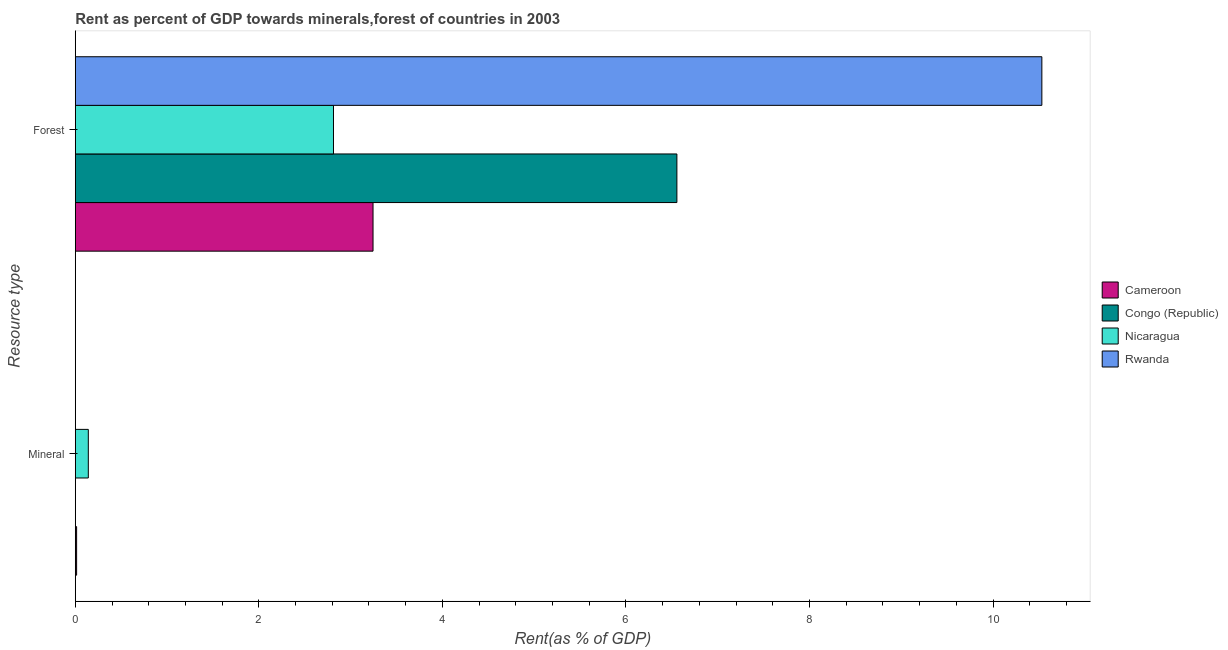How many different coloured bars are there?
Offer a terse response. 4. How many bars are there on the 2nd tick from the top?
Provide a succinct answer. 4. How many bars are there on the 1st tick from the bottom?
Your answer should be compact. 4. What is the label of the 1st group of bars from the top?
Your answer should be very brief. Forest. What is the forest rent in Cameroon?
Your answer should be compact. 3.24. Across all countries, what is the maximum forest rent?
Ensure brevity in your answer.  10.53. Across all countries, what is the minimum forest rent?
Your response must be concise. 2.81. In which country was the forest rent maximum?
Keep it short and to the point. Rwanda. In which country was the forest rent minimum?
Offer a terse response. Nicaragua. What is the total mineral rent in the graph?
Provide a succinct answer. 0.16. What is the difference between the mineral rent in Nicaragua and that in Rwanda?
Offer a terse response. 0.14. What is the difference between the forest rent in Congo (Republic) and the mineral rent in Cameroon?
Make the answer very short. 6.54. What is the average forest rent per country?
Provide a succinct answer. 5.79. What is the difference between the mineral rent and forest rent in Nicaragua?
Your answer should be compact. -2.67. In how many countries, is the forest rent greater than 4 %?
Your response must be concise. 2. What is the ratio of the mineral rent in Congo (Republic) to that in Nicaragua?
Your answer should be compact. 0. Is the mineral rent in Congo (Republic) less than that in Nicaragua?
Offer a very short reply. Yes. What does the 3rd bar from the top in Forest represents?
Ensure brevity in your answer.  Congo (Republic). What does the 3rd bar from the bottom in Mineral represents?
Offer a terse response. Nicaragua. Are all the bars in the graph horizontal?
Keep it short and to the point. Yes. Are the values on the major ticks of X-axis written in scientific E-notation?
Offer a very short reply. No. Does the graph contain grids?
Your answer should be very brief. No. How are the legend labels stacked?
Give a very brief answer. Vertical. What is the title of the graph?
Give a very brief answer. Rent as percent of GDP towards minerals,forest of countries in 2003. What is the label or title of the X-axis?
Offer a terse response. Rent(as % of GDP). What is the label or title of the Y-axis?
Offer a very short reply. Resource type. What is the Rent(as % of GDP) of Cameroon in Mineral?
Keep it short and to the point. 0.01. What is the Rent(as % of GDP) of Congo (Republic) in Mineral?
Ensure brevity in your answer.  0. What is the Rent(as % of GDP) of Nicaragua in Mineral?
Offer a terse response. 0.14. What is the Rent(as % of GDP) in Rwanda in Mineral?
Make the answer very short. 0. What is the Rent(as % of GDP) of Cameroon in Forest?
Offer a very short reply. 3.24. What is the Rent(as % of GDP) of Congo (Republic) in Forest?
Offer a terse response. 6.56. What is the Rent(as % of GDP) in Nicaragua in Forest?
Your response must be concise. 2.81. What is the Rent(as % of GDP) of Rwanda in Forest?
Your answer should be very brief. 10.53. Across all Resource type, what is the maximum Rent(as % of GDP) in Cameroon?
Your answer should be very brief. 3.24. Across all Resource type, what is the maximum Rent(as % of GDP) in Congo (Republic)?
Provide a succinct answer. 6.56. Across all Resource type, what is the maximum Rent(as % of GDP) in Nicaragua?
Provide a short and direct response. 2.81. Across all Resource type, what is the maximum Rent(as % of GDP) in Rwanda?
Keep it short and to the point. 10.53. Across all Resource type, what is the minimum Rent(as % of GDP) of Cameroon?
Your answer should be very brief. 0.01. Across all Resource type, what is the minimum Rent(as % of GDP) of Congo (Republic)?
Ensure brevity in your answer.  0. Across all Resource type, what is the minimum Rent(as % of GDP) in Nicaragua?
Give a very brief answer. 0.14. Across all Resource type, what is the minimum Rent(as % of GDP) in Rwanda?
Provide a short and direct response. 0. What is the total Rent(as % of GDP) of Cameroon in the graph?
Provide a short and direct response. 3.26. What is the total Rent(as % of GDP) in Congo (Republic) in the graph?
Your response must be concise. 6.56. What is the total Rent(as % of GDP) in Nicaragua in the graph?
Offer a very short reply. 2.96. What is the total Rent(as % of GDP) in Rwanda in the graph?
Your answer should be compact. 10.53. What is the difference between the Rent(as % of GDP) in Cameroon in Mineral and that in Forest?
Ensure brevity in your answer.  -3.23. What is the difference between the Rent(as % of GDP) of Congo (Republic) in Mineral and that in Forest?
Ensure brevity in your answer.  -6.55. What is the difference between the Rent(as % of GDP) in Nicaragua in Mineral and that in Forest?
Your response must be concise. -2.67. What is the difference between the Rent(as % of GDP) of Rwanda in Mineral and that in Forest?
Make the answer very short. -10.53. What is the difference between the Rent(as % of GDP) in Cameroon in Mineral and the Rent(as % of GDP) in Congo (Republic) in Forest?
Give a very brief answer. -6.54. What is the difference between the Rent(as % of GDP) of Cameroon in Mineral and the Rent(as % of GDP) of Nicaragua in Forest?
Your answer should be very brief. -2.8. What is the difference between the Rent(as % of GDP) in Cameroon in Mineral and the Rent(as % of GDP) in Rwanda in Forest?
Make the answer very short. -10.52. What is the difference between the Rent(as % of GDP) of Congo (Republic) in Mineral and the Rent(as % of GDP) of Nicaragua in Forest?
Offer a terse response. -2.81. What is the difference between the Rent(as % of GDP) of Congo (Republic) in Mineral and the Rent(as % of GDP) of Rwanda in Forest?
Make the answer very short. -10.53. What is the difference between the Rent(as % of GDP) in Nicaragua in Mineral and the Rent(as % of GDP) in Rwanda in Forest?
Your response must be concise. -10.39. What is the average Rent(as % of GDP) of Cameroon per Resource type?
Provide a short and direct response. 1.63. What is the average Rent(as % of GDP) in Congo (Republic) per Resource type?
Provide a short and direct response. 3.28. What is the average Rent(as % of GDP) in Nicaragua per Resource type?
Keep it short and to the point. 1.48. What is the average Rent(as % of GDP) in Rwanda per Resource type?
Offer a very short reply. 5.27. What is the difference between the Rent(as % of GDP) in Cameroon and Rent(as % of GDP) in Congo (Republic) in Mineral?
Provide a short and direct response. 0.01. What is the difference between the Rent(as % of GDP) of Cameroon and Rent(as % of GDP) of Nicaragua in Mineral?
Keep it short and to the point. -0.13. What is the difference between the Rent(as % of GDP) of Cameroon and Rent(as % of GDP) of Rwanda in Mineral?
Offer a terse response. 0.01. What is the difference between the Rent(as % of GDP) in Congo (Republic) and Rent(as % of GDP) in Nicaragua in Mineral?
Your response must be concise. -0.14. What is the difference between the Rent(as % of GDP) of Congo (Republic) and Rent(as % of GDP) of Rwanda in Mineral?
Provide a succinct answer. -0. What is the difference between the Rent(as % of GDP) of Nicaragua and Rent(as % of GDP) of Rwanda in Mineral?
Offer a terse response. 0.14. What is the difference between the Rent(as % of GDP) of Cameroon and Rent(as % of GDP) of Congo (Republic) in Forest?
Ensure brevity in your answer.  -3.31. What is the difference between the Rent(as % of GDP) of Cameroon and Rent(as % of GDP) of Nicaragua in Forest?
Your answer should be very brief. 0.43. What is the difference between the Rent(as % of GDP) in Cameroon and Rent(as % of GDP) in Rwanda in Forest?
Your answer should be very brief. -7.29. What is the difference between the Rent(as % of GDP) of Congo (Republic) and Rent(as % of GDP) of Nicaragua in Forest?
Provide a short and direct response. 3.74. What is the difference between the Rent(as % of GDP) in Congo (Republic) and Rent(as % of GDP) in Rwanda in Forest?
Your response must be concise. -3.98. What is the difference between the Rent(as % of GDP) of Nicaragua and Rent(as % of GDP) of Rwanda in Forest?
Provide a succinct answer. -7.72. What is the ratio of the Rent(as % of GDP) of Cameroon in Mineral to that in Forest?
Your answer should be compact. 0. What is the ratio of the Rent(as % of GDP) in Congo (Republic) in Mineral to that in Forest?
Your response must be concise. 0. What is the ratio of the Rent(as % of GDP) in Nicaragua in Mineral to that in Forest?
Your answer should be very brief. 0.05. What is the ratio of the Rent(as % of GDP) of Rwanda in Mineral to that in Forest?
Offer a very short reply. 0. What is the difference between the highest and the second highest Rent(as % of GDP) of Cameroon?
Offer a very short reply. 3.23. What is the difference between the highest and the second highest Rent(as % of GDP) in Congo (Republic)?
Provide a succinct answer. 6.55. What is the difference between the highest and the second highest Rent(as % of GDP) in Nicaragua?
Ensure brevity in your answer.  2.67. What is the difference between the highest and the second highest Rent(as % of GDP) in Rwanda?
Keep it short and to the point. 10.53. What is the difference between the highest and the lowest Rent(as % of GDP) of Cameroon?
Your answer should be compact. 3.23. What is the difference between the highest and the lowest Rent(as % of GDP) in Congo (Republic)?
Your response must be concise. 6.55. What is the difference between the highest and the lowest Rent(as % of GDP) of Nicaragua?
Your response must be concise. 2.67. What is the difference between the highest and the lowest Rent(as % of GDP) of Rwanda?
Your response must be concise. 10.53. 